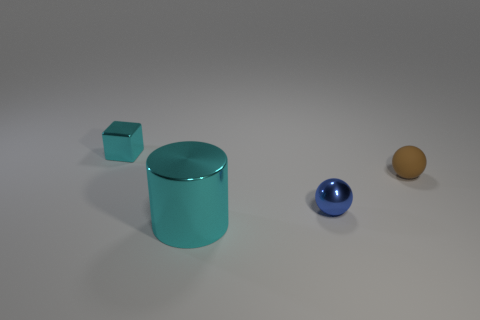Add 3 small metal objects. How many objects exist? 7 Subtract all brown spheres. How many spheres are left? 1 Subtract all cylinders. How many objects are left? 3 Subtract all blue spheres. How many red cylinders are left? 0 Add 4 tiny cyan shiny things. How many tiny cyan shiny things are left? 5 Add 1 large purple matte cylinders. How many large purple matte cylinders exist? 1 Subtract 0 green blocks. How many objects are left? 4 Subtract all red blocks. Subtract all gray cylinders. How many blocks are left? 1 Subtract all large shiny objects. Subtract all green balls. How many objects are left? 3 